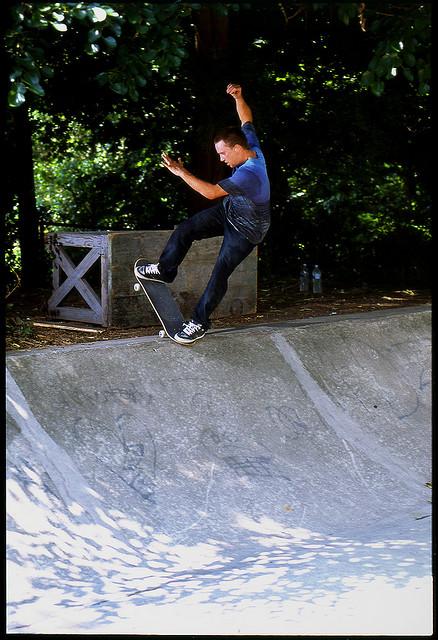How many people are in this picture?
Quick response, please. 1. Does someone have a baby in the park?
Write a very short answer. No. What is the boy riding?
Be succinct. Skateboard. How many people have skateboards?
Give a very brief answer. 1. Is he wearing a watch?
Keep it brief. No. What color is his shirt?
Give a very brief answer. Blue. Is this man flipping his skateboard?
Short answer required. No. What color is the skater's shirt?
Answer briefly. Blue. What is the man looking at?
Be succinct. Skateboard. Is this a tennis court?
Answer briefly. No. Is he wearing protective gear?
Answer briefly. No. Are both of the boy's feet touching the skateboard?
Short answer required. Yes. What is the ramp made of?
Concise answer only. Concrete. 